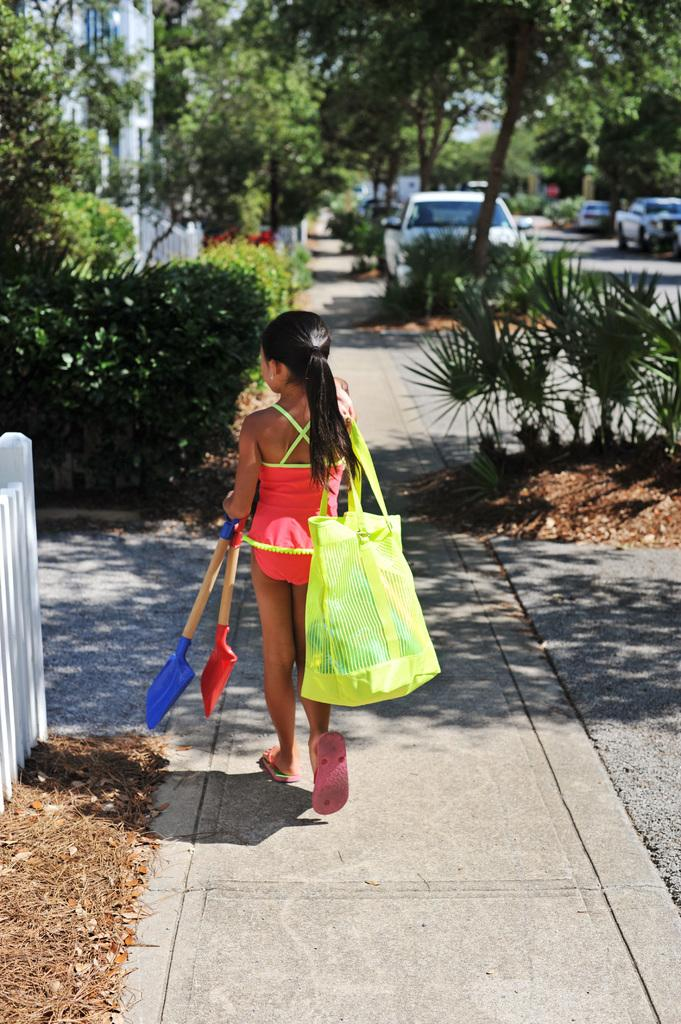What is the main subject in the foreground of the image? There is a small girl in the foreground of the image. What is the girl holding in the image? The girl is holding a carry bag. What can be seen in the background of the image? There are trees, vehicles, plants, and a building in the background of the image. What type of drain is visible in the image? There is no drain present in the image. What is the size of the loaf of bread in the image? There is no loaf of bread present in the image. 